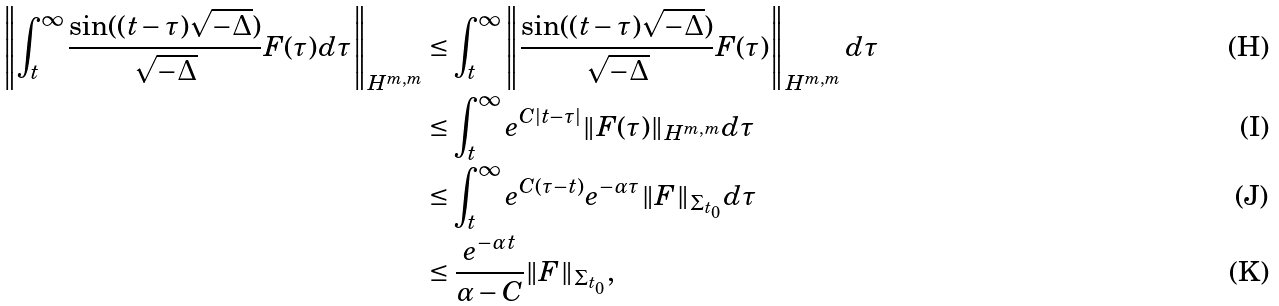Convert formula to latex. <formula><loc_0><loc_0><loc_500><loc_500>\left \| \int _ { t } ^ { \infty } \frac { \sin ( ( t - \tau ) \sqrt { - \Delta } ) } { \sqrt { - \Delta } } F ( \tau ) d \tau \right \| _ { H ^ { m , m } } & \leq \int _ { t } ^ { \infty } \left \| \frac { \sin ( ( t - \tau ) \sqrt { - \Delta } ) } { \sqrt { - \Delta } } F ( \tau ) \right \| _ { H ^ { m , m } } d \tau \\ & \leq \int _ { t } ^ { \infty } e ^ { C | t - \tau | } \| F ( \tau ) \| _ { H ^ { m , m } } d \tau \\ & \leq \int _ { t } ^ { \infty } e ^ { C ( \tau - t ) } e ^ { - \alpha \tau } \| F \| _ { \Sigma _ { t _ { 0 } } } d \tau \\ & \leq \frac { e ^ { - \alpha t } } { \alpha - C } \| F \| _ { \Sigma _ { t _ { 0 } } } ,</formula> 